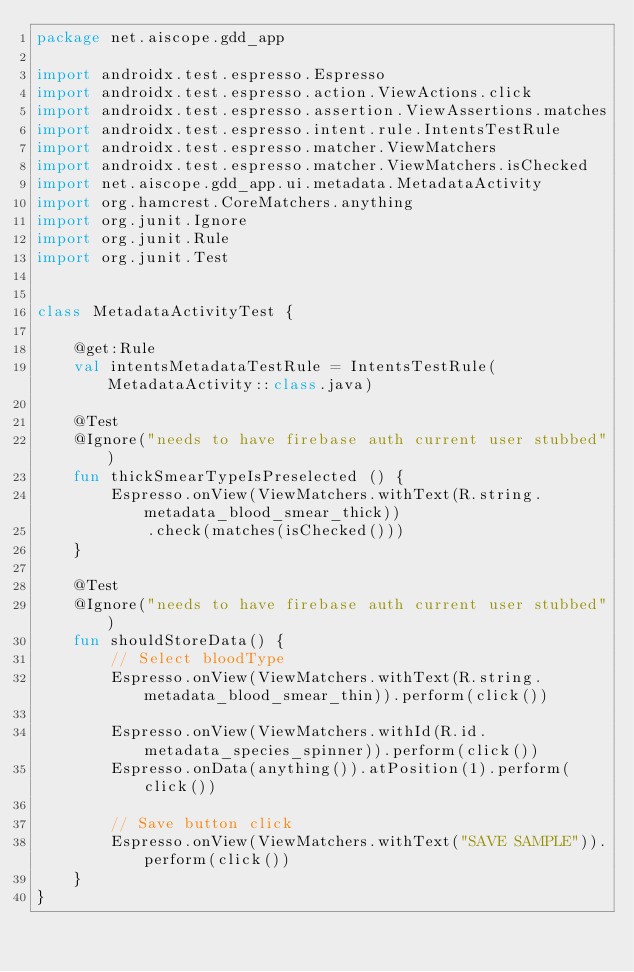Convert code to text. <code><loc_0><loc_0><loc_500><loc_500><_Kotlin_>package net.aiscope.gdd_app

import androidx.test.espresso.Espresso
import androidx.test.espresso.action.ViewActions.click
import androidx.test.espresso.assertion.ViewAssertions.matches
import androidx.test.espresso.intent.rule.IntentsTestRule
import androidx.test.espresso.matcher.ViewMatchers
import androidx.test.espresso.matcher.ViewMatchers.isChecked
import net.aiscope.gdd_app.ui.metadata.MetadataActivity
import org.hamcrest.CoreMatchers.anything
import org.junit.Ignore
import org.junit.Rule
import org.junit.Test


class MetadataActivityTest {

    @get:Rule
    val intentsMetadataTestRule = IntentsTestRule(MetadataActivity::class.java)

    @Test
    @Ignore("needs to have firebase auth current user stubbed")
    fun thickSmearTypeIsPreselected () {
        Espresso.onView(ViewMatchers.withText(R.string.metadata_blood_smear_thick))
            .check(matches(isChecked()))
    }

    @Test
    @Ignore("needs to have firebase auth current user stubbed")
    fun shouldStoreData() {
        // Select bloodType
        Espresso.onView(ViewMatchers.withText(R.string.metadata_blood_smear_thin)).perform(click())

        Espresso.onView(ViewMatchers.withId(R.id.metadata_species_spinner)).perform(click())
        Espresso.onData(anything()).atPosition(1).perform(click())

        // Save button click
        Espresso.onView(ViewMatchers.withText("SAVE SAMPLE")).perform(click())
    }
}
</code> 